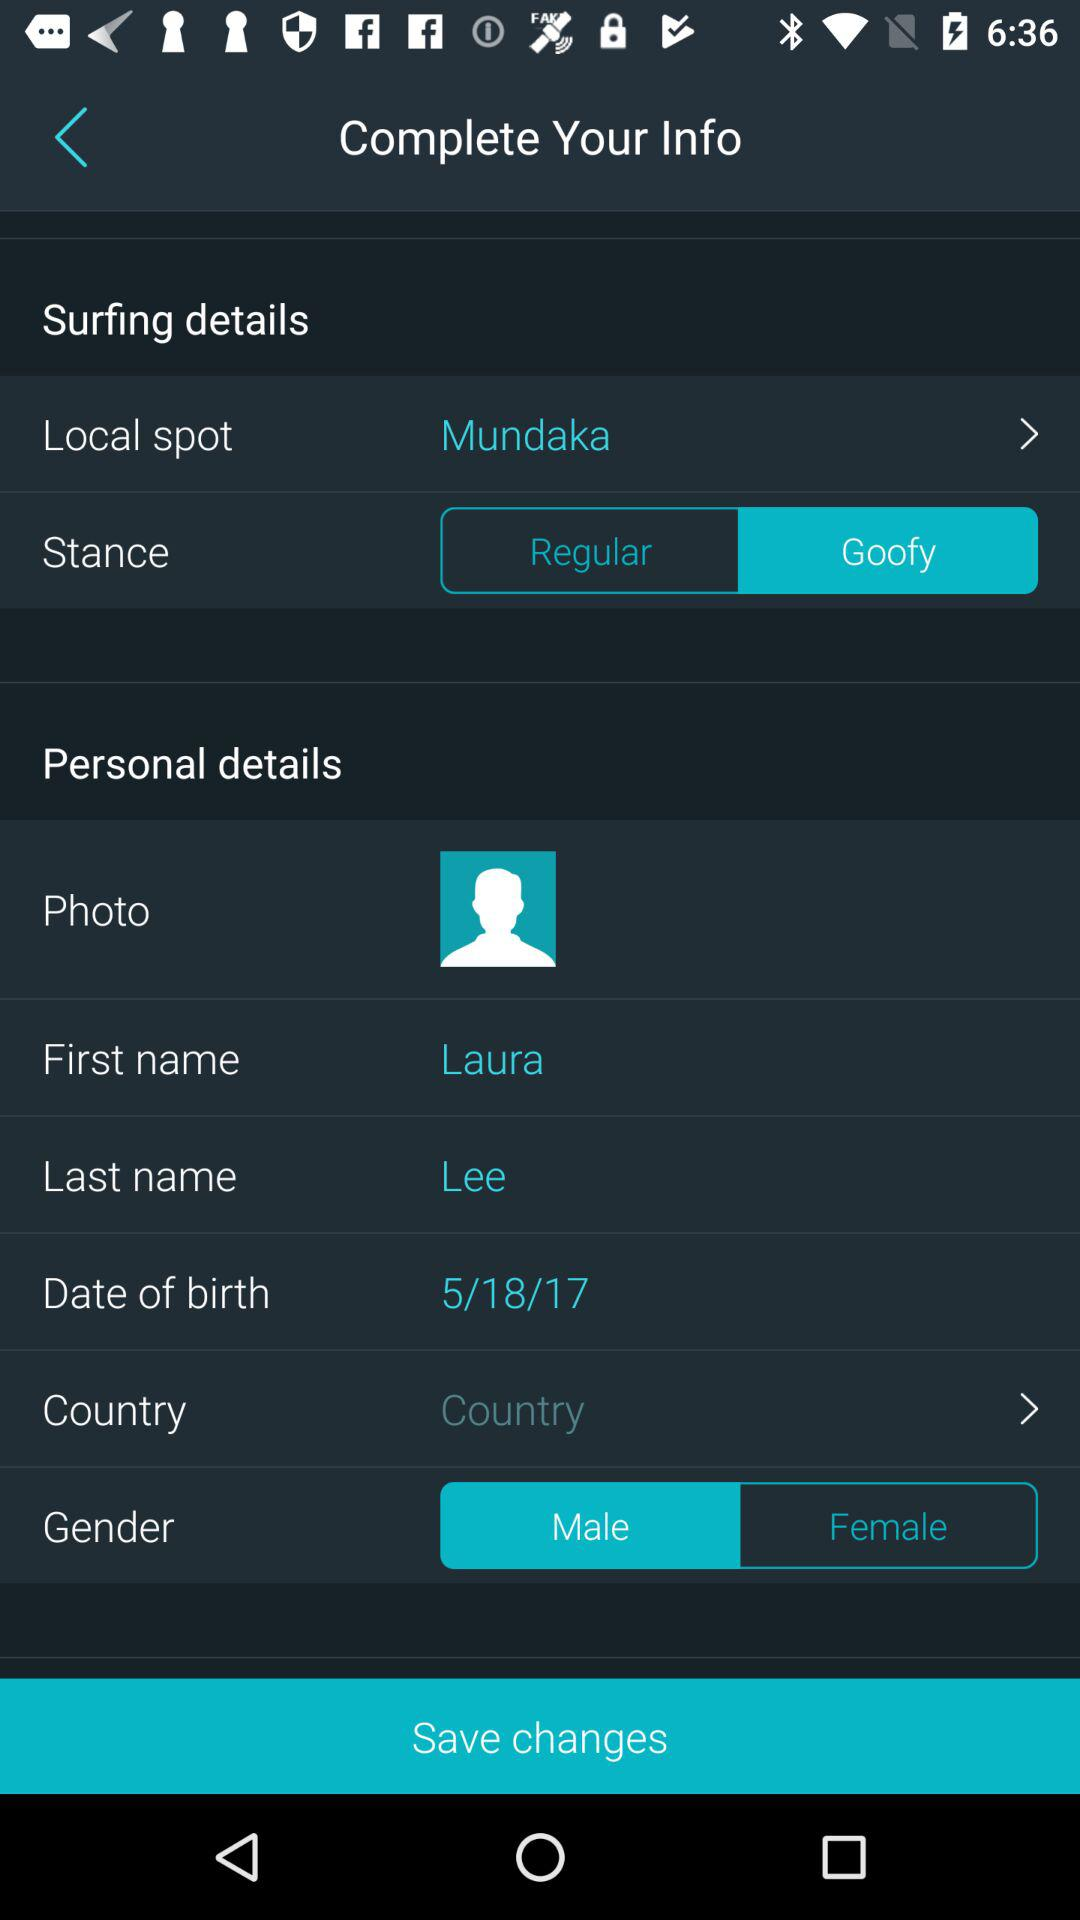How many more personal details are there than surfing details?
Answer the question using a single word or phrase. 4 